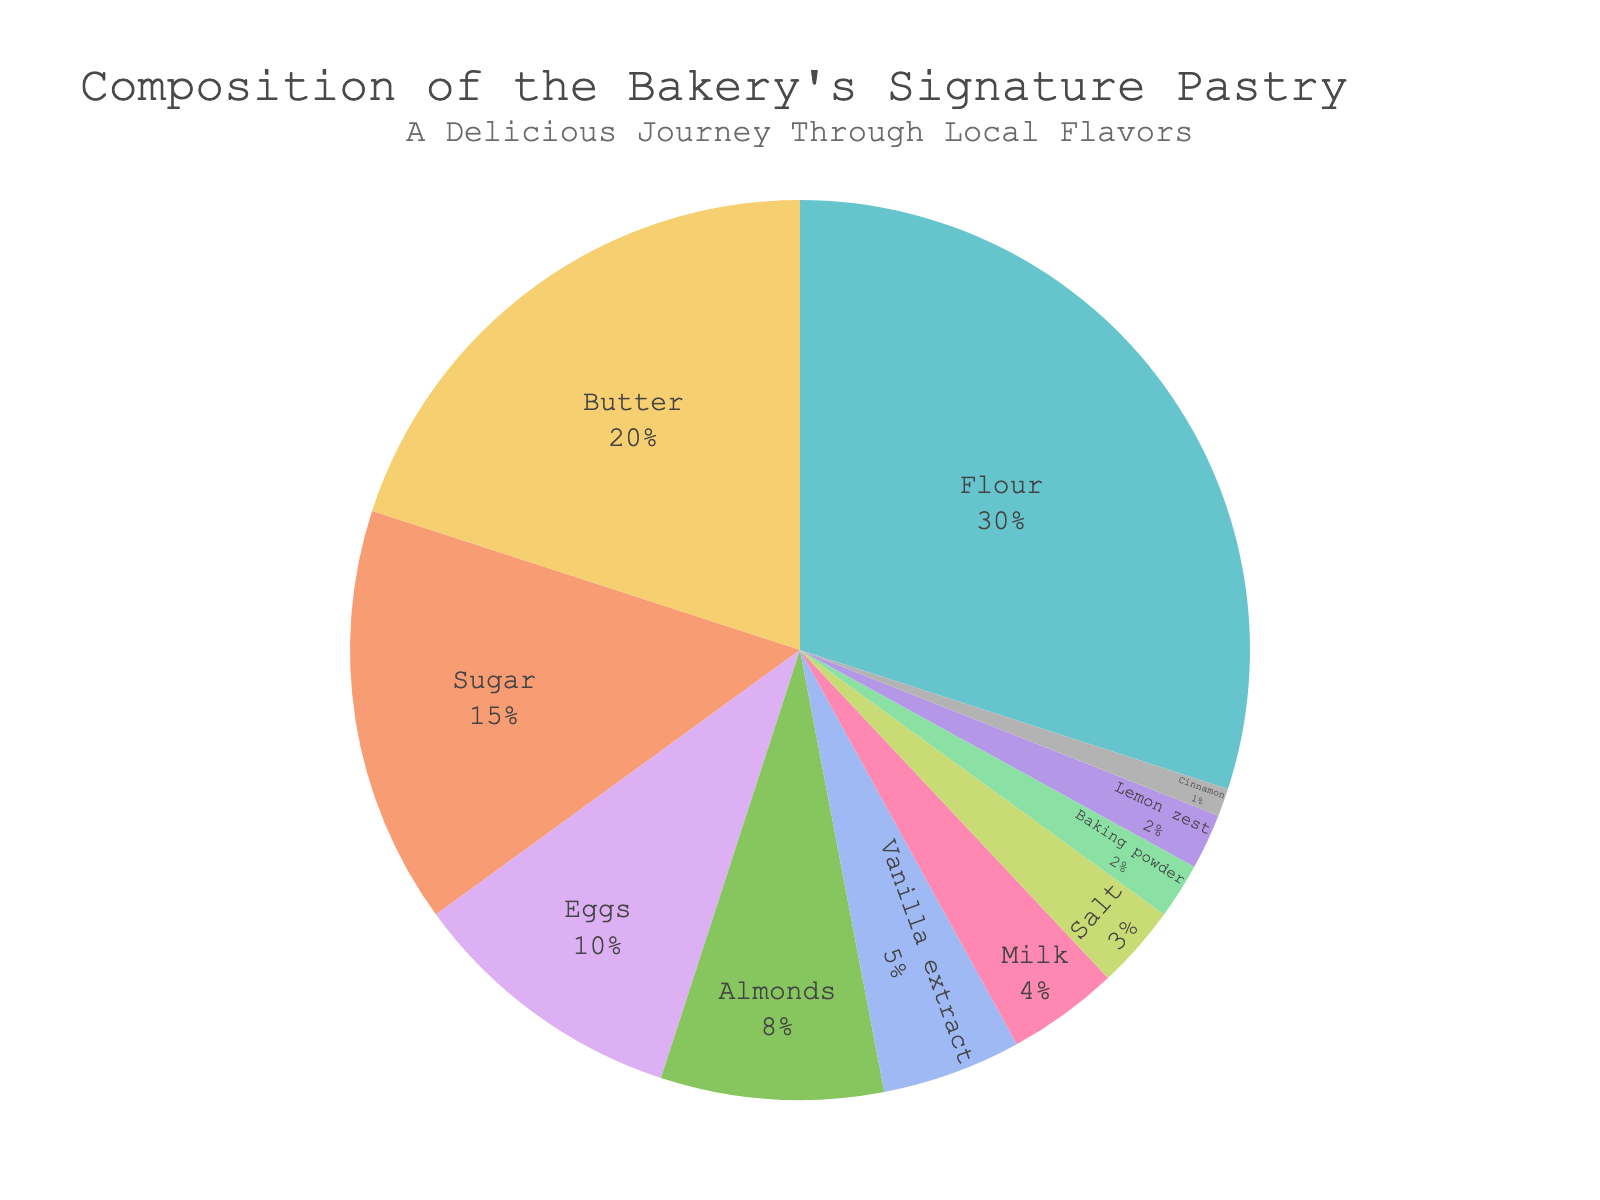What ingredient is used the most in the bakery's signature pastry? The pie chart shows that Flour has the largest percentage at 30%, making it the most used ingredient.
Answer: Flour Which ingredient is used the least in the bakery’s signature pastry? The pie chart shows that Cinnamon has the smallest percentage at 1%, making it the least used ingredient.
Answer: Cinnamon What is the total percentage of the top three ingredients combined? The top three ingredients are Flour (30%), Butter (20%), and Sugar (15%). Adding these percentages gives us 30% + 20% + 15% = 65%.
Answer: 65% Is the percentage of Butter greater than the percentage of Eggs? The pie chart shows that Butter is 20% and Eggs are 10%. Since 20% is greater than 10%, the percentage of Butter is indeed greater.
Answer: Yes How much more is the percentage of Flour compared to Baking powder? The percentage of Flour is 30% and the percentage of Baking powder is 2%. The difference between these two is 30% - 2% = 28%.
Answer: 28% What is the combined percentage of all ingredients that are used less than 10%? The ingredients used less than 10% are Almonds (8%), Vanilla extract (5%), Milk (4%), Salt (3%), Baking powder (2%), Lemon zest (2%), and Cinnamon (1%). Adding these percentages gives us 8% + 5% + 4% + 3% + 2% + 2% + 1% = 25%.
Answer: 25% Between Almonds and Vanilla extract, which ingredient has a higher percentage, and by how much? The pie chart shows that Almonds have a percentage of 8% and Vanilla extract is at 5%. The difference between them is 8% - 5% = 3%, with Almonds having a higher percentage.
Answer: Almonds, by 3% What ingredients make up less than 5% each of the total composition? The pie chart shows that Milk (4%), Salt (3%), Baking powder (2%), Lemon zest (2%), and Cinnamon (1%) are each less than 5% of the total composition.
Answer: Milk, Salt, Baking powder, Lemon zest, Cinnamon Which has a higher percentage, the combination of Eggs and Almonds or the combination of Sugar and Milk? The pie chart shows Eggs at 10% and Almonds at 8%, totaling 18%. Sugar is 15% and Milk is 4%, totaling 19%. Since 19% is greater than 18%, the combination of Sugar and Milk is higher.
Answer: Sugar and Milk How does the percentage of Sugar compare to the total percentage of Eggs and Vanilla extract combined? The pie chart shows Sugar at 15%, Eggs at 10%, and Vanilla extract at 5%. The total percentage of Eggs and Vanilla extract is 10% + 5% = 15%, which is equal to the percentage of Sugar.
Answer: Equal 